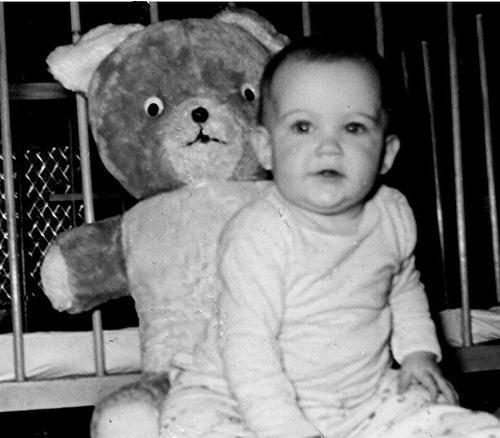Evaluate: Does the caption "The person is behind the teddy bear." match the image?
Answer yes or no. No. Is the given caption "The teddy bear is close to the person." fitting for the image?
Answer yes or no. Yes. 